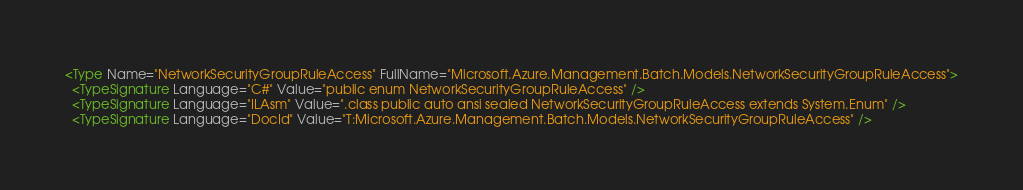Convert code to text. <code><loc_0><loc_0><loc_500><loc_500><_XML_><Type Name="NetworkSecurityGroupRuleAccess" FullName="Microsoft.Azure.Management.Batch.Models.NetworkSecurityGroupRuleAccess">
  <TypeSignature Language="C#" Value="public enum NetworkSecurityGroupRuleAccess" />
  <TypeSignature Language="ILAsm" Value=".class public auto ansi sealed NetworkSecurityGroupRuleAccess extends System.Enum" />
  <TypeSignature Language="DocId" Value="T:Microsoft.Azure.Management.Batch.Models.NetworkSecurityGroupRuleAccess" /></code> 